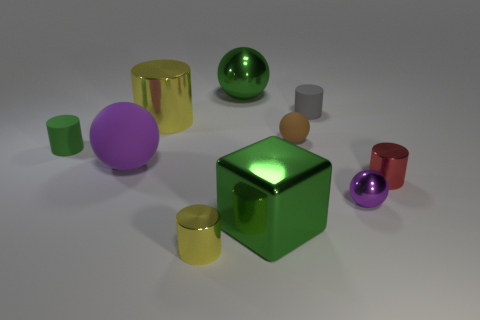Subtract all gray cylinders. How many cylinders are left? 4 Subtract all green cylinders. How many cylinders are left? 4 Subtract all blue spheres. Subtract all cyan cylinders. How many spheres are left? 4 Subtract all spheres. How many objects are left? 6 Subtract all tiny brown rubber balls. Subtract all green rubber cylinders. How many objects are left? 8 Add 8 tiny gray objects. How many tiny gray objects are left? 9 Add 7 red metallic cylinders. How many red metallic cylinders exist? 8 Subtract 1 green blocks. How many objects are left? 9 